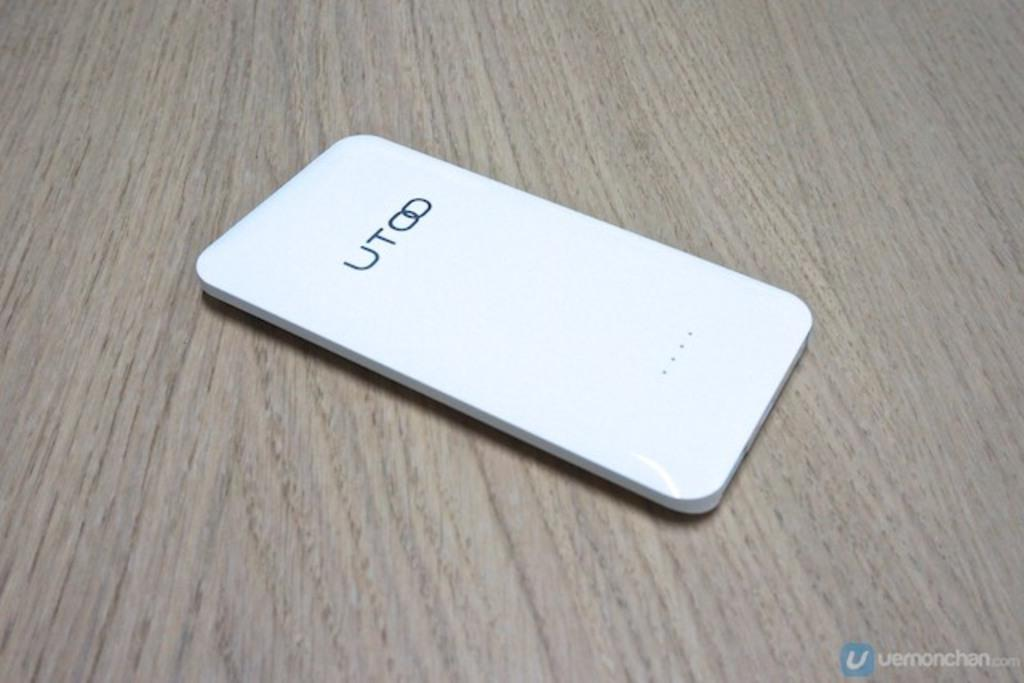Provide a one-sentence caption for the provided image. A phone manufactured by UTOO laying on a wood grained table. 